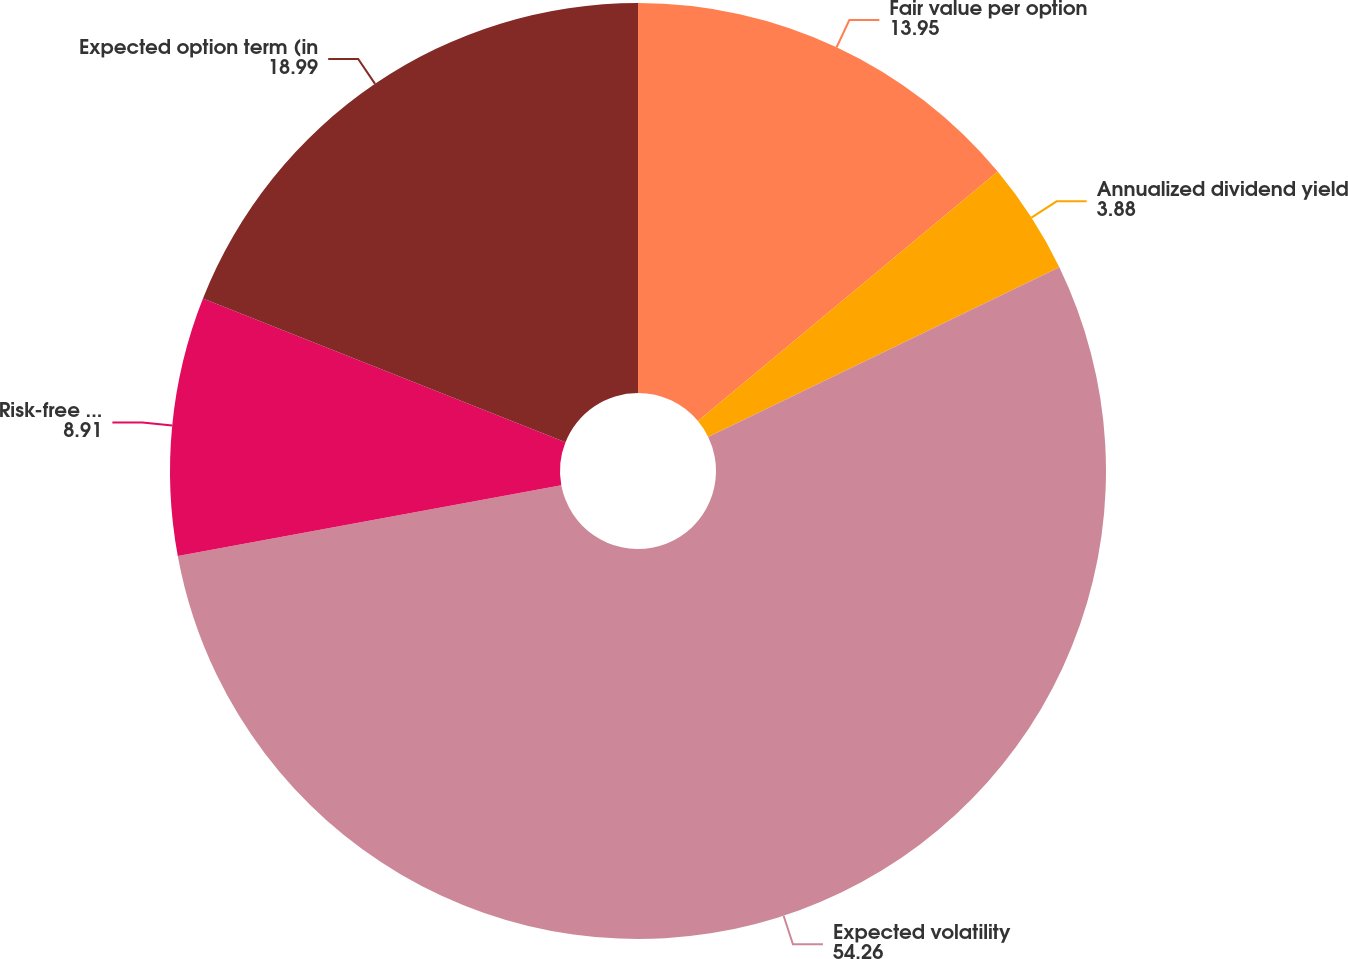Convert chart to OTSL. <chart><loc_0><loc_0><loc_500><loc_500><pie_chart><fcel>Fair value per option<fcel>Annualized dividend yield<fcel>Expected volatility<fcel>Risk-free interest rate<fcel>Expected option term (in<nl><fcel>13.95%<fcel>3.88%<fcel>54.26%<fcel>8.91%<fcel>18.99%<nl></chart> 